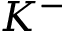Convert formula to latex. <formula><loc_0><loc_0><loc_500><loc_500>K ^ { - }</formula> 